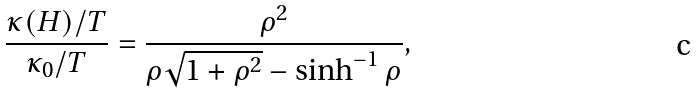Convert formula to latex. <formula><loc_0><loc_0><loc_500><loc_500>\frac { \kappa ( H ) / T } { \kappa _ { 0 } / T } = \frac { \rho ^ { 2 } } { \rho \sqrt { 1 + \rho ^ { 2 } } - \sinh ^ { - 1 } \rho } ,</formula> 